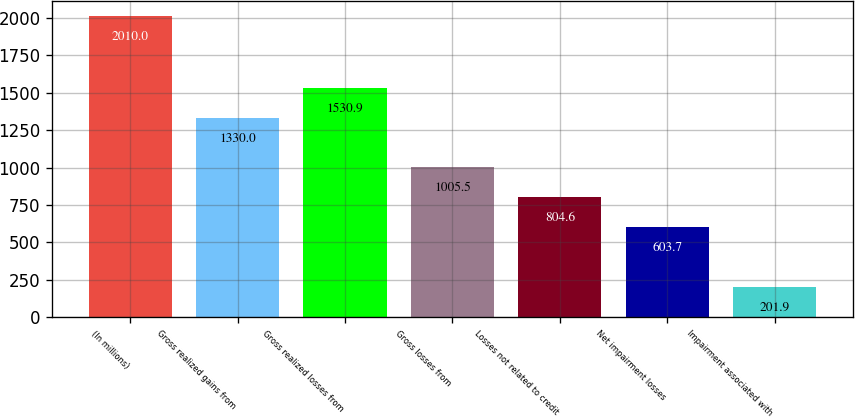<chart> <loc_0><loc_0><loc_500><loc_500><bar_chart><fcel>(In millions)<fcel>Gross realized gains from<fcel>Gross realized losses from<fcel>Gross losses from<fcel>Losses not related to credit<fcel>Net impairment losses<fcel>Impairment associated with<nl><fcel>2010<fcel>1330<fcel>1530.9<fcel>1005.5<fcel>804.6<fcel>603.7<fcel>201.9<nl></chart> 